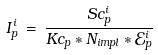<formula> <loc_0><loc_0><loc_500><loc_500>I _ { p } ^ { i } \, = \, \frac { S c _ { p } ^ { i } } { K c _ { p } * N _ { i m p l } * \mathcal { E } _ { p } ^ { i } }</formula> 